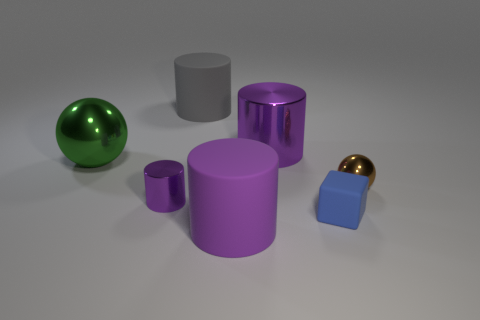Are there any other things that are the same shape as the small matte thing?
Provide a succinct answer. No. Do the tiny metallic cylinder and the big shiny cylinder have the same color?
Keep it short and to the point. Yes. What is the color of the big metallic object that is the same shape as the large gray matte thing?
Keep it short and to the point. Purple. What number of matte things are both in front of the brown metal thing and left of the big metallic cylinder?
Your answer should be compact. 1. Is the number of tiny balls behind the gray object greater than the number of small purple objects left of the tiny blue matte thing?
Offer a very short reply. No. How big is the gray thing?
Offer a very short reply. Large. Are there any big purple things that have the same shape as the small purple object?
Your response must be concise. Yes. There is a large purple rubber object; is its shape the same as the large matte thing that is behind the tiny blue object?
Give a very brief answer. Yes. What size is the metal object that is to the right of the big purple matte object and on the left side of the brown metal thing?
Provide a succinct answer. Large. What number of tiny brown things are there?
Your response must be concise. 1. 